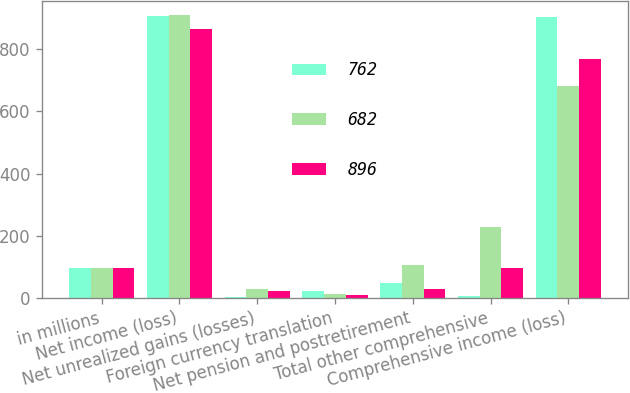Convert chart to OTSL. <chart><loc_0><loc_0><loc_500><loc_500><stacked_bar_chart><ecel><fcel>in millions<fcel>Net income (loss)<fcel>Net unrealized gains (losses)<fcel>Foreign currency translation<fcel>Net pension and postretirement<fcel>Total other comprehensive<fcel>Comprehensive income (loss)<nl><fcel>762<fcel>96<fcel>907<fcel>3<fcel>20<fcel>46<fcel>4<fcel>903<nl><fcel>682<fcel>96<fcel>910<fcel>29<fcel>13<fcel>106<fcel>228<fcel>682<nl><fcel>896<fcel>96<fcel>865<fcel>20<fcel>10<fcel>28<fcel>96<fcel>769<nl></chart> 